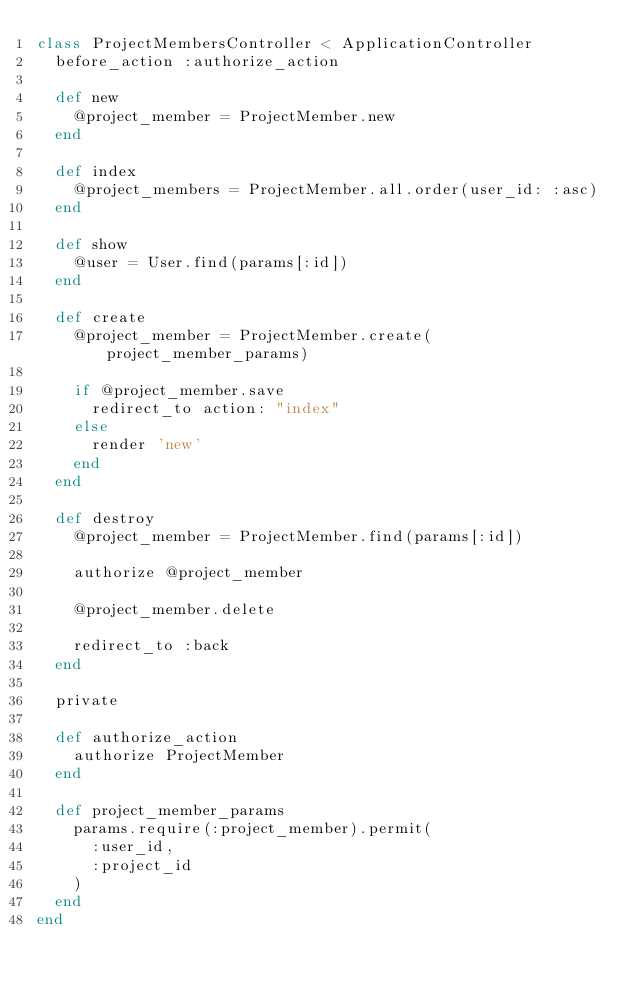<code> <loc_0><loc_0><loc_500><loc_500><_Ruby_>class ProjectMembersController < ApplicationController
  before_action :authorize_action

  def new
    @project_member = ProjectMember.new
  end

  def index
    @project_members = ProjectMember.all.order(user_id: :asc)
  end

  def show
    @user = User.find(params[:id])
  end

  def create
    @project_member = ProjectMember.create(project_member_params)

    if @project_member.save
      redirect_to action: "index"
    else
      render 'new'
    end
  end

  def destroy
    @project_member = ProjectMember.find(params[:id])

    authorize @project_member

    @project_member.delete

    redirect_to :back
  end

  private

  def authorize_action
    authorize ProjectMember
  end

  def project_member_params
    params.require(:project_member).permit(
      :user_id,
      :project_id
    )
  end
end
</code> 